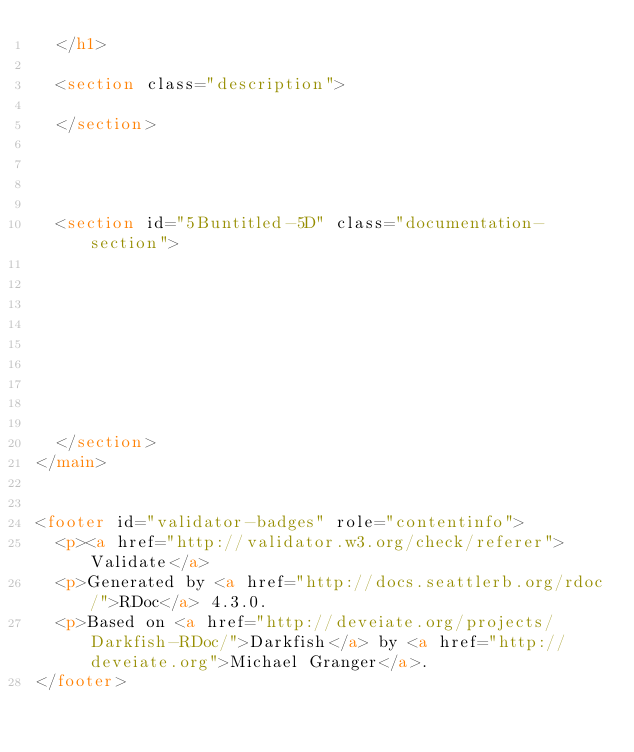Convert code to text. <code><loc_0><loc_0><loc_500><loc_500><_HTML_>  </h1>

  <section class="description">
    
  </section>

  
  
  
  <section id="5Buntitled-5D" class="documentation-section">
    

    

    

    

    
  </section>
</main>


<footer id="validator-badges" role="contentinfo">
  <p><a href="http://validator.w3.org/check/referer">Validate</a>
  <p>Generated by <a href="http://docs.seattlerb.org/rdoc/">RDoc</a> 4.3.0.
  <p>Based on <a href="http://deveiate.org/projects/Darkfish-RDoc/">Darkfish</a> by <a href="http://deveiate.org">Michael Granger</a>.
</footer>

</code> 